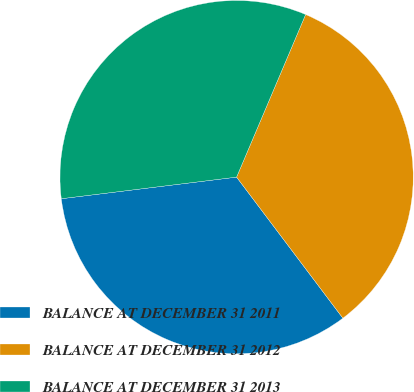Convert chart. <chart><loc_0><loc_0><loc_500><loc_500><pie_chart><fcel>BALANCE AT DECEMBER 31 2011<fcel>BALANCE AT DECEMBER 31 2012<fcel>BALANCE AT DECEMBER 31 2013<nl><fcel>33.32%<fcel>33.33%<fcel>33.34%<nl></chart> 